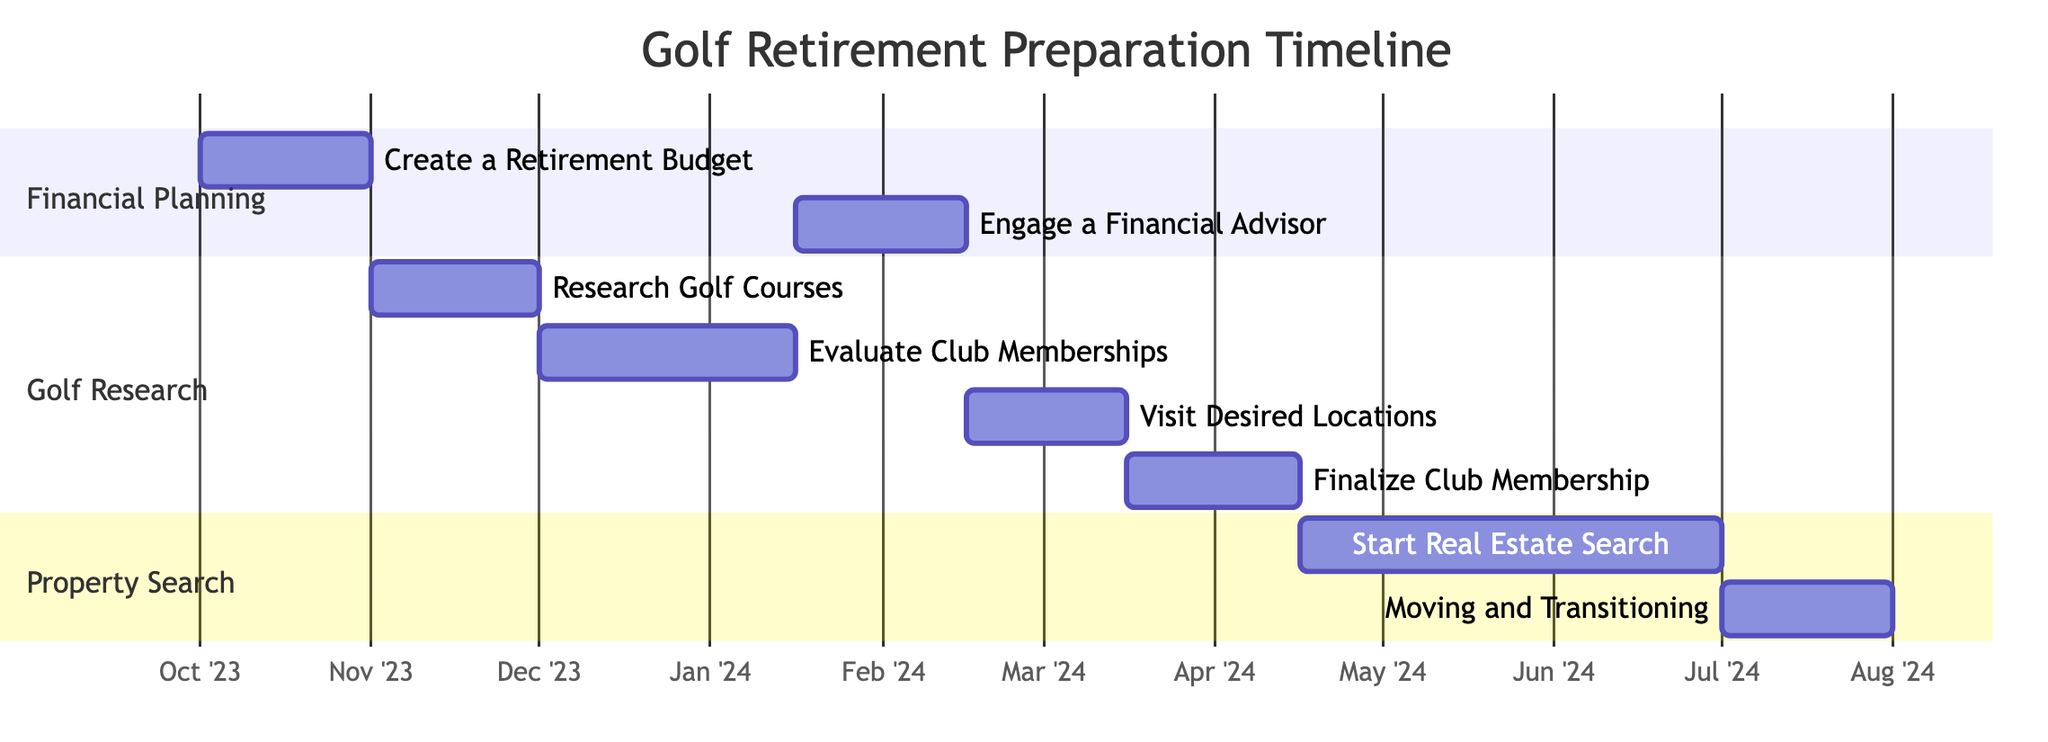What is the duration of the task "Create a Retirement Budget"? The task "Create a Retirement Budget" starts on October 1, 2023, and ends on October 31, 2023. This means it lasts for 31 days.
Answer: 31 days Which task follows "Evaluate Club Membership Options"? The Gantt Chart shows that "Evaluate Club Membership Options" ends on January 15, 2024, and "Engage a Financial Advisor" starts immediately after on January 16, 2024.
Answer: Engage a Financial Advisor How many tasks are in the Financial Planning section? The Financial Planning section includes two tasks: "Create a Retirement Budget" and "Engage a Financial Advisor." Counting these gives a total of two tasks.
Answer: 2 What is the starting date for the "Visit Desired Locations for Golf Properties"? The task "Visit Desired Locations for Golf Properties" is indicated to start on February 16, 2024, as specified in the timeline of the Gantt Chart.
Answer: February 16, 2024 What is the total duration of the tasks in the Golf Research section? To find the total duration: "Research Golf Courses" lasts 30 days, "Evaluate Club Membership Options" lasts 46 days, "Visit Desired Locations" lasts 29 days, and "Finalize Golf Club Membership" lasts 31 days. Adding these together gives 30 + 46 + 29 + 31 = 136 days.
Answer: 136 days Which task has the longest duration overall? By comparing all task durations, "Start Real Estate Search for Retirement Property" lasts 76 days, which is longer than any other task in the chart.
Answer: Start Real Estate Search for Retirement Property What is the end date of the "Moving and Transitioning" task? The task "Moving and Transitioning" starts on July 1, 2024, and lasts for 31 days, thus it ends on July 31, 2024.
Answer: July 31, 2024 How do the "Engage a Financial Advisor" and "Visit Desired Locations" tasks relate temporally? The task "Engage a Financial Advisor" runs from January 16 to February 15, 2024, and "Visit Desired Locations" starts on February 16, 2024, making them consecutive tasks with no overlap.
Answer: Consecutive 